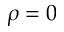<formula> <loc_0><loc_0><loc_500><loc_500>\rho = 0</formula> 